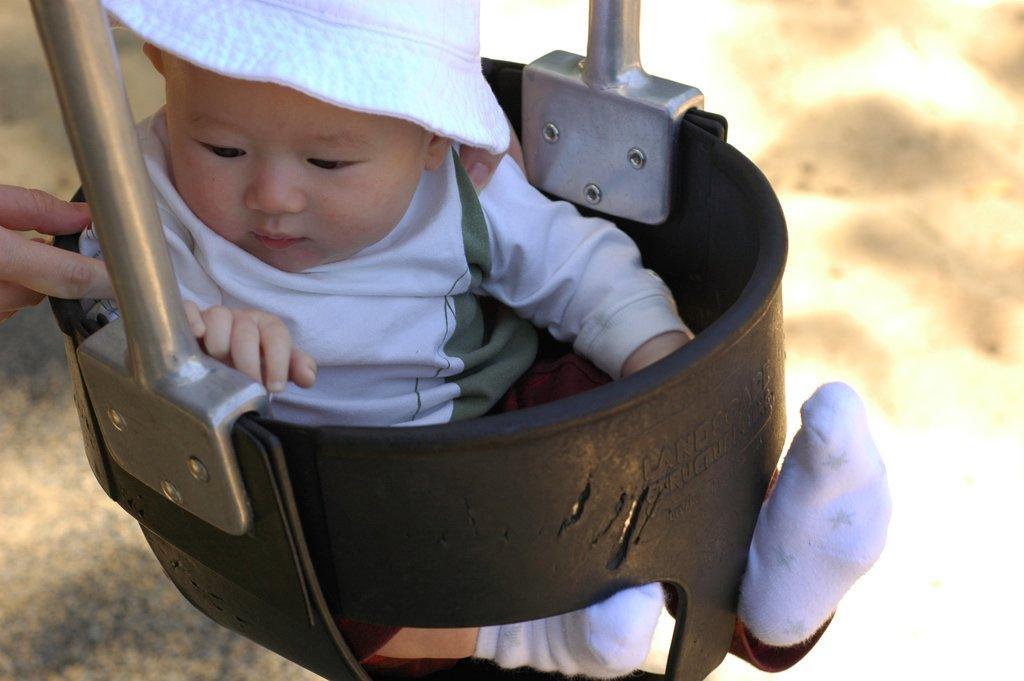How would you summarize this image in a sentence or two? In this picture there is a boy who is wearing hat, t-shirt, short and socks. He is sitting on the basket. On the left we can see the person's hand. 